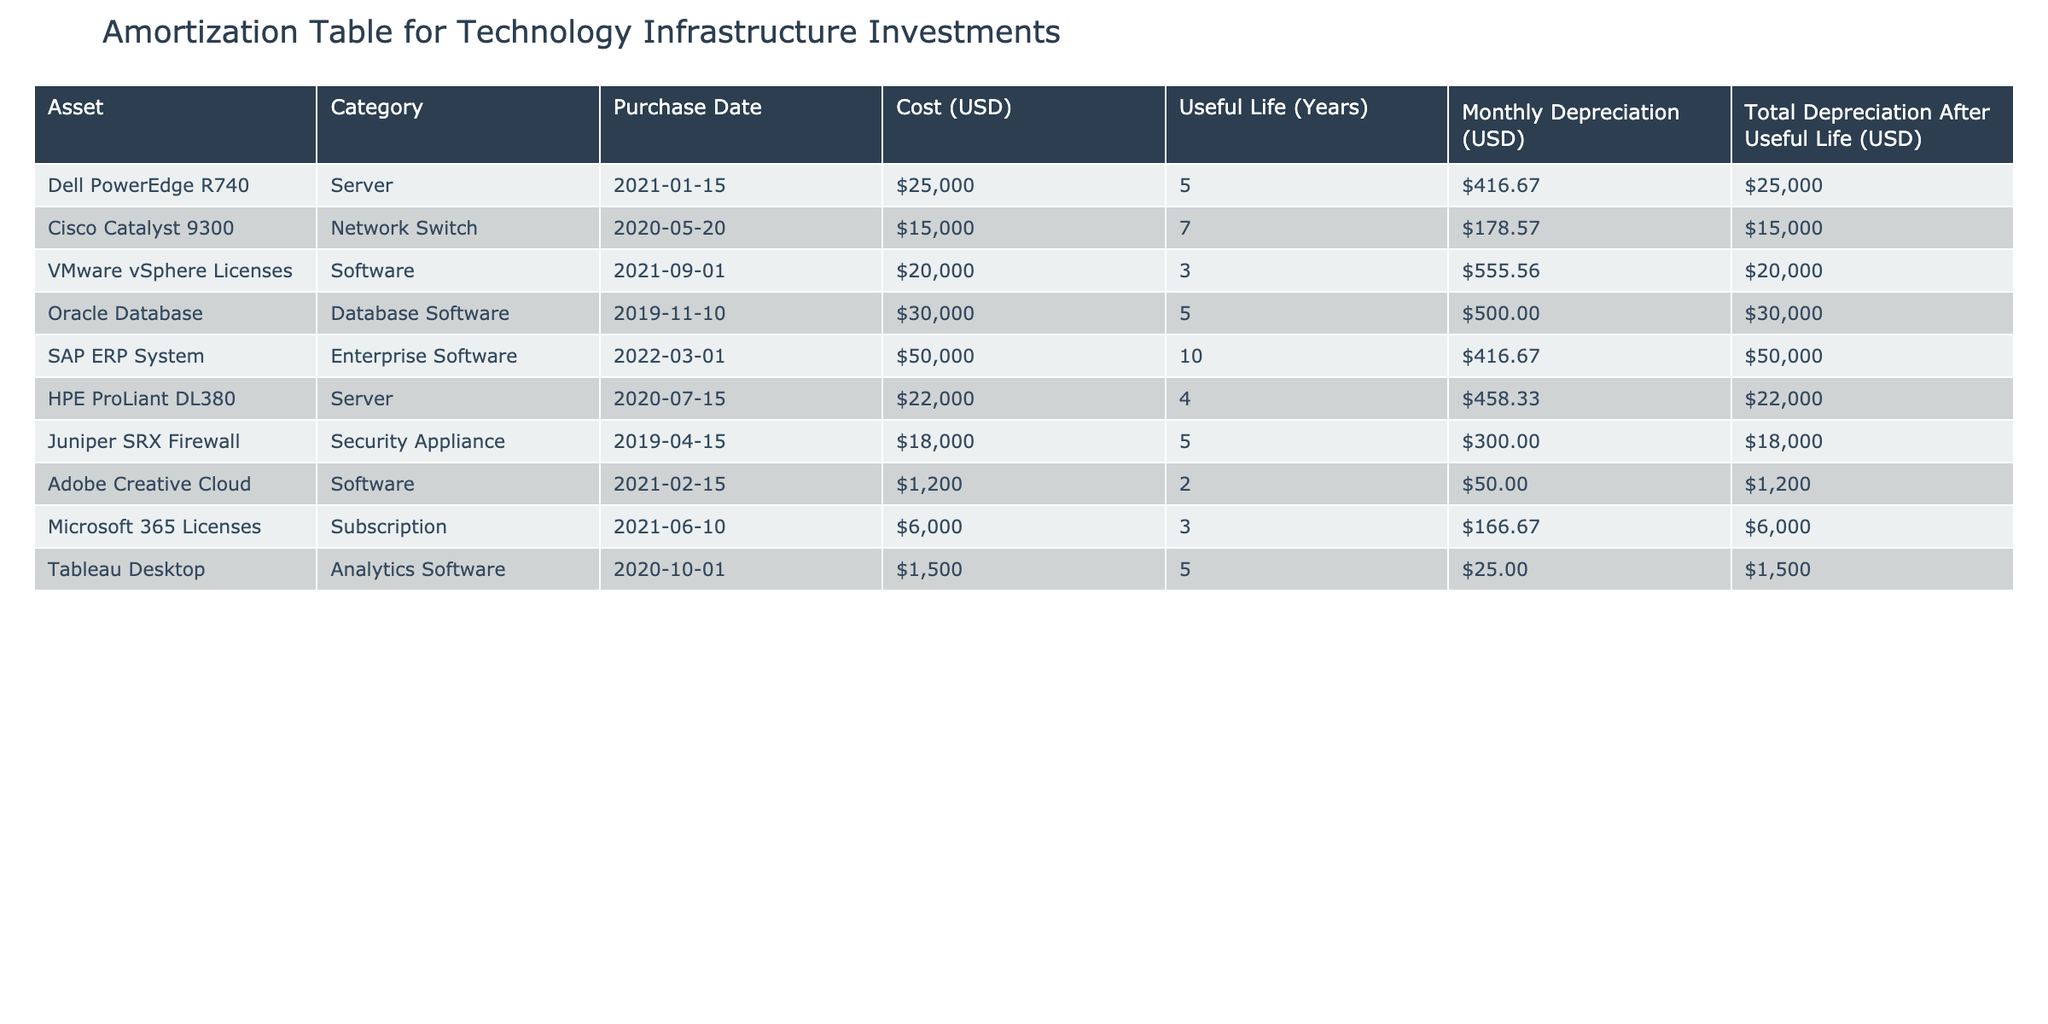What is the total cost of all assets listed in the table? To find the total cost, sum up the 'Cost (USD)' values of each asset in the table: 25000 + 15000 + 20000 + 30000 + 50000 + 22000 + 18000 + 1200 + 6000 + 1500 = 197700.
Answer: 197700 Which software asset has the highest monthly depreciation cost? The monthly depreciation costs for software assets are: VMware vSphere Licenses at 555.56, Oracle Database at 500.00, Adobe Creative Cloud at 50.00, and Microsoft 365 Licenses at 166.67. The highest is VMware vSphere Licenses at 555.56.
Answer: VMware vSphere Licenses Is the total depreciation of the SAP ERP System greater than the total depreciation of the Cisco Catalyst 9300? The total depreciation for SAP ERP System is 50000 and for Cisco Catalyst 9300 is 15000. Since 50000 is greater than 15000, the answer is yes.
Answer: Yes What is the average useful life of all server and software assets combined? The useful lives are: Dell PowerEdge R740 (5), HPE ProLiant DL380 (4), VMware vSphere Licenses (3), and Adobe Creative Cloud (2). Sum = 5 + 4 + 3 + 2 = 14 months and there are 4 assets, thus average = 14 / 4 = 3.5 years.
Answer: 3.5 How many assets have a useful life greater than 5 years? From the table, assets with useful life greater than 5 years are: Cisco Catalyst 9300 (7 years) and SAP ERP System (10 years), totaling 2 assets.
Answer: 2 What is the monthly depreciation for the Oracle Database? The monthly depreciation cost for the Oracle Database is specifically listed in the table as 500.00.
Answer: 500.00 Is there more total depreciation from software assets than from server assets? Total depreciation from software assets: VMware vSphere Licenses (20000) + Oracle Database (30000) + Adobe Creative Cloud (1200) + Microsoft 365 Licenses (6000) = 37200. From server assets: Dell PowerEdge R740 (25000) + HPE ProLiant DL380 (22000) = 47000. Since 37200 is less than 47000, the answer is no.
Answer: No How does the total cost of network switch compare to the security appliance? The cost of Cisco Catalyst 9300 (network switch) is 15000 and Juniper SRX Firewall (security appliance) is 18000. Since 15000 is less than 18000, the network switch has a lower cost.
Answer: Lower cost 